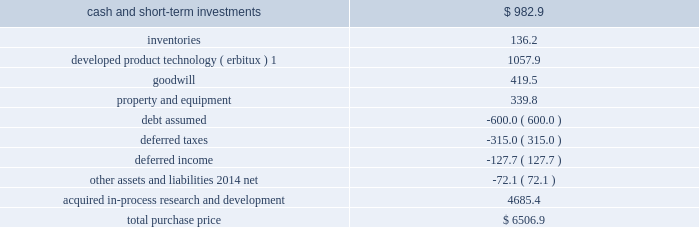For marketing .
There are several methods that can be used to determine the estimated fair value of the ipr&d acquired in a business combination .
We utilized the 201cincome method , 201d which applies a probability weighting to the estimated future net cash fl ows that are derived from projected sales revenues and estimated costs .
These projec- tions are based on factors such as relevant market size , patent protection , historical pricing of similar products , and expected industry trends .
The estimated future net cash fl ows are then discounted to the present value using an appropriate discount rate .
This analysis is performed for each project independently .
In accordance with fin 4 , applicability of fasb statement no .
2 to business combinations accounted for by the purchase method , these acquired ipr&d intangible assets totaling $ 4.71 billion and $ 340.5 million in 2008 and 2007 , respectively , were expensed immediately subsequent to the acquisition because the products had no alternative future use .
The ongoing activities with respect to each of these products in development are not material to our research and development expenses .
In addition to the acquisitions of businesses , we also acquired several products in development .
The acquired ipr&d related to these products of $ 122.0 million and $ 405.1 million in 2008 and 2007 , respectively , was also writ- ten off by a charge to income immediately upon acquisition because the products had no alternative future use .
Imclone acquisition on november 24 , 2008 , we acquired all of the outstanding shares of imclone systems inc .
( imclone ) , a biopharma- ceutical company focused on advancing oncology care , for a total purchase price of approximately $ 6.5 billion , which was fi nanced through borrowings .
This strategic combination will offer both targeted therapies and oncolytic agents along with a pipeline spanning all phases of clinical development .
The combination also expands our bio- technology capabilities .
The acquisition has been accounted for as a business combination under the purchase method of accounting , resulting in goodwill of $ 419.5 million .
No portion of this goodwill is expected to be deductible for tax purposes .
Allocation of purchase price we are currently determining the fair values of a signifi cant portion of these net assets .
The purchase price has been preliminarily allocated based on an estimate of the fair value of assets acquired and liabilities assumed as of the date of acquisition .
The fi nal determination of these fair values will be completed as soon as possible but no later than one year from the acquisition date .
Although the fi nal determination may result in asset and liability fair values that are different than the preliminary estimates of these amounts included herein , it is not expected that those differences will be material to our fi nancial results .
Estimated fair value at november 24 , 2008 .
1this intangible asset will be amortized on a straight-line basis through 2023 in the u.s .
And 2018 in the rest of the world .
All of the estimated fair value of the acquired ipr&d is attributable to oncology-related products in develop- ment , including $ 1.33 billion to line extensions for erbitux .
A signifi cant portion ( 81 percent ) of the remaining value of acquired ipr&d is attributable to two compounds in phase iii clinical testing and one compound in phase ii clini- cal testing , all targeted to treat various forms of cancers .
The discount rate we used in valuing the acquired ipr&d projects was 13.5 percent , and the charge for acquired ipr&d of $ 4.69 billion recorded in the fourth quarter of 2008 , was not deductible for tax purposes .
Pro forma financial information the following unaudited pro forma fi nancial information presents the combined results of our operations with .
What i the yearly amortization expense related to developed product technology? 
Computations: (1057.9 / (2023 - 2008))
Answer: 70.52667. 